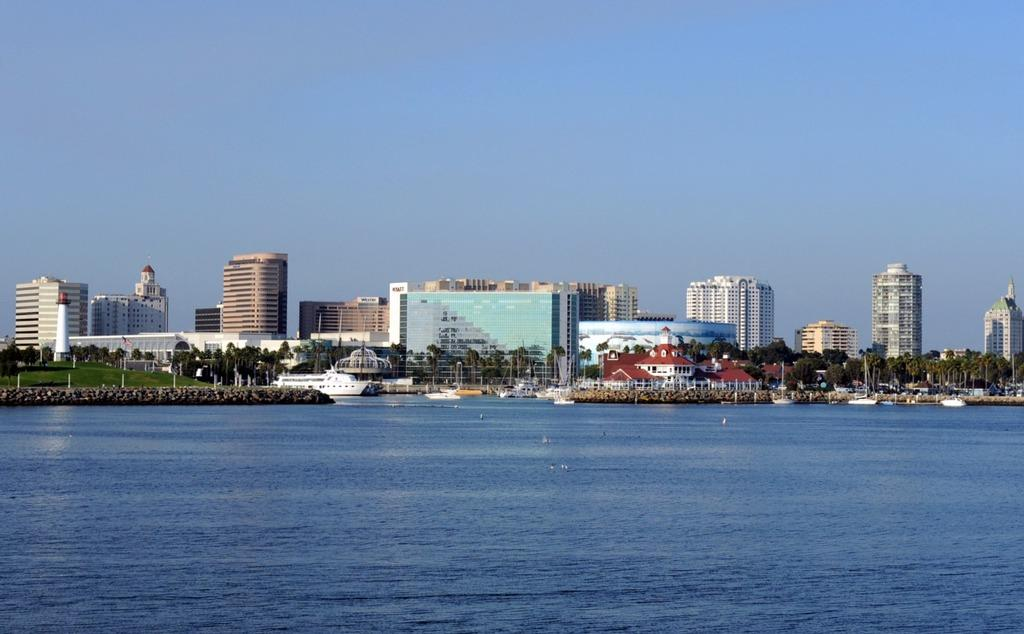What type of structures can be seen in the image? There are many buildings in the image. What type of vegetation is present in the image? There are trees and grass in the image. What objects can be seen in the image besides buildings and vegetation? There are poles, water, and a ship in the water visible in the image. What is the color of the sky in the image? The sky is pale blue in the image. Can you see a farm in the image? There is no farm present in the image. What type of utensil is being used to stir the water in the image? There is no utensil or stirring action depicted in the image. 